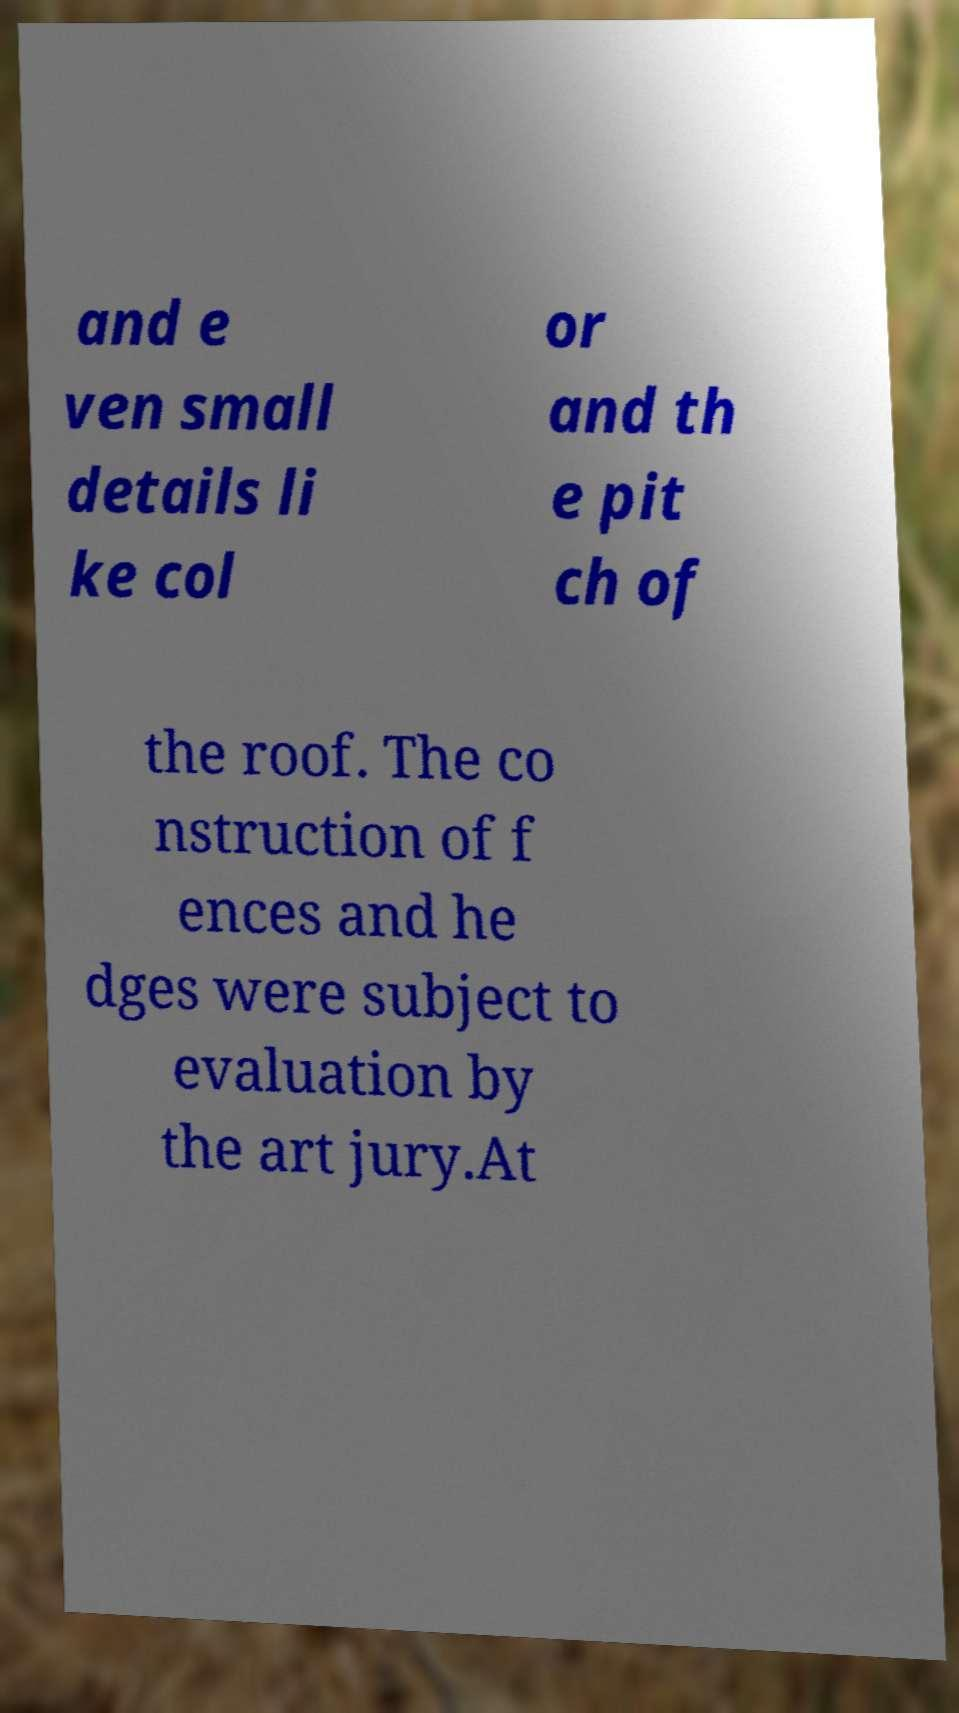For documentation purposes, I need the text within this image transcribed. Could you provide that? and e ven small details li ke col or and th e pit ch of the roof. The co nstruction of f ences and he dges were subject to evaluation by the art jury.At 